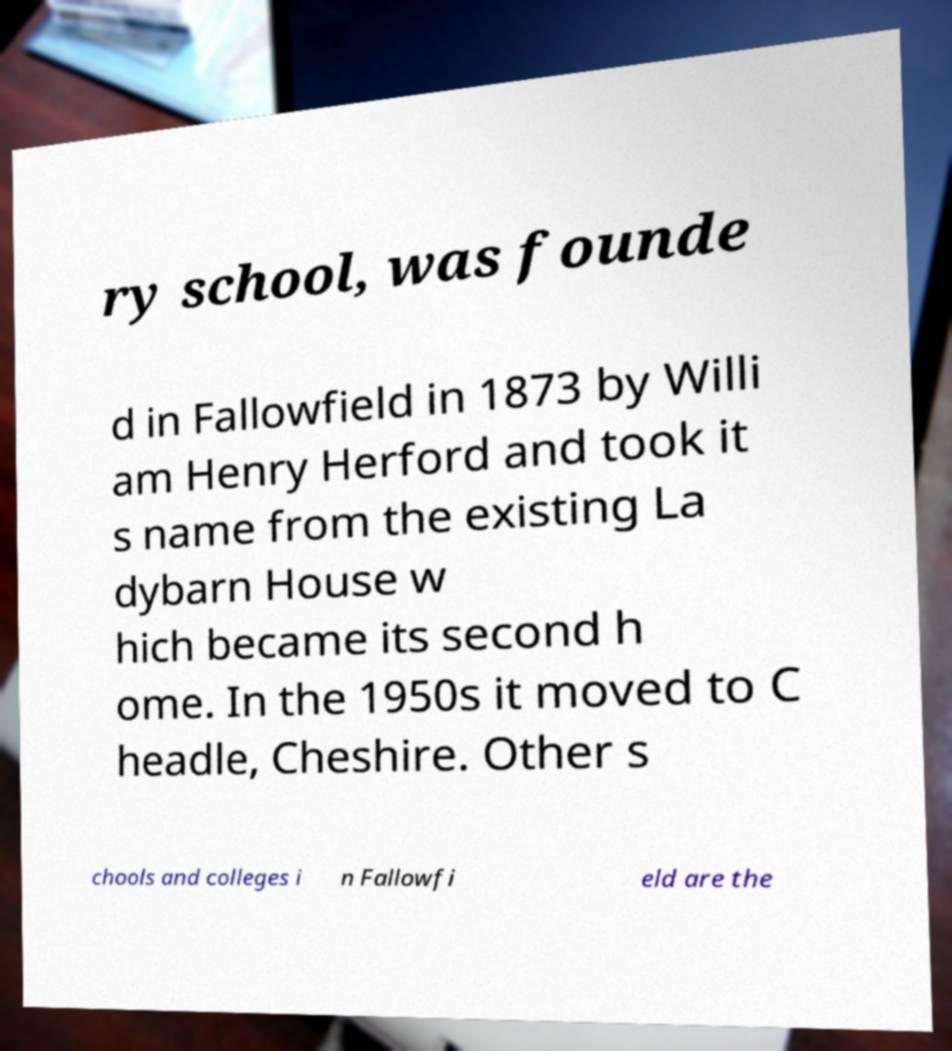Could you extract and type out the text from this image? ry school, was founde d in Fallowfield in 1873 by Willi am Henry Herford and took it s name from the existing La dybarn House w hich became its second h ome. In the 1950s it moved to C headle, Cheshire. Other s chools and colleges i n Fallowfi eld are the 